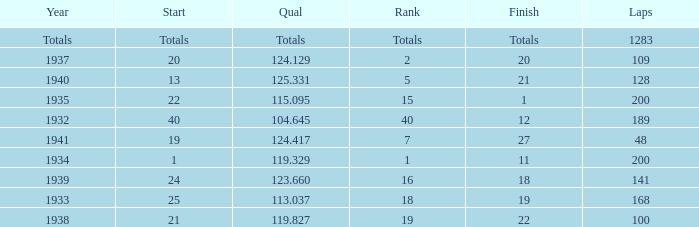What was the finish place with a qual of 123.660? 18.0. 